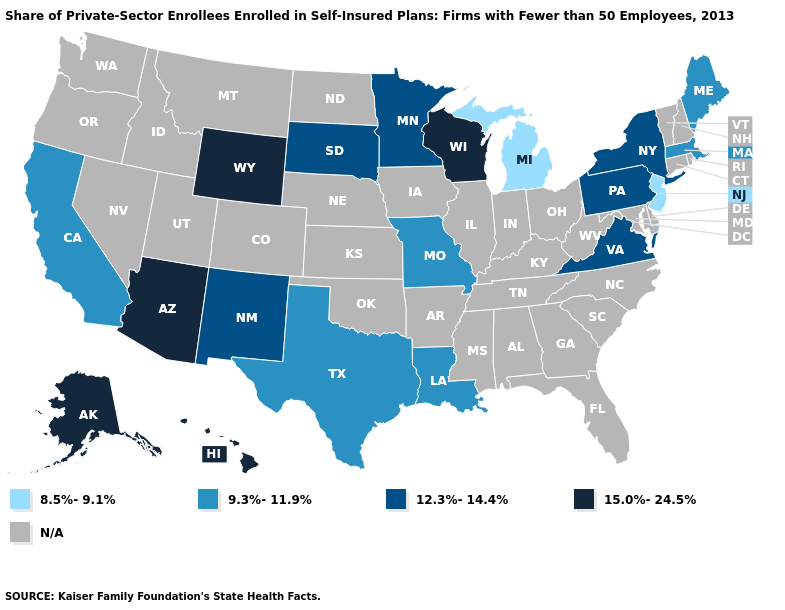Among the states that border New Mexico , does Texas have the highest value?
Be succinct. No. Name the states that have a value in the range N/A?
Keep it brief. Alabama, Arkansas, Colorado, Connecticut, Delaware, Florida, Georgia, Idaho, Illinois, Indiana, Iowa, Kansas, Kentucky, Maryland, Mississippi, Montana, Nebraska, Nevada, New Hampshire, North Carolina, North Dakota, Ohio, Oklahoma, Oregon, Rhode Island, South Carolina, Tennessee, Utah, Vermont, Washington, West Virginia. Name the states that have a value in the range N/A?
Be succinct. Alabama, Arkansas, Colorado, Connecticut, Delaware, Florida, Georgia, Idaho, Illinois, Indiana, Iowa, Kansas, Kentucky, Maryland, Mississippi, Montana, Nebraska, Nevada, New Hampshire, North Carolina, North Dakota, Ohio, Oklahoma, Oregon, Rhode Island, South Carolina, Tennessee, Utah, Vermont, Washington, West Virginia. Name the states that have a value in the range N/A?
Be succinct. Alabama, Arkansas, Colorado, Connecticut, Delaware, Florida, Georgia, Idaho, Illinois, Indiana, Iowa, Kansas, Kentucky, Maryland, Mississippi, Montana, Nebraska, Nevada, New Hampshire, North Carolina, North Dakota, Ohio, Oklahoma, Oregon, Rhode Island, South Carolina, Tennessee, Utah, Vermont, Washington, West Virginia. Name the states that have a value in the range 12.3%-14.4%?
Be succinct. Minnesota, New Mexico, New York, Pennsylvania, South Dakota, Virginia. What is the value of Minnesota?
Write a very short answer. 12.3%-14.4%. Among the states that border Delaware , does New Jersey have the lowest value?
Answer briefly. Yes. What is the value of Massachusetts?
Answer briefly. 9.3%-11.9%. Name the states that have a value in the range N/A?
Concise answer only. Alabama, Arkansas, Colorado, Connecticut, Delaware, Florida, Georgia, Idaho, Illinois, Indiana, Iowa, Kansas, Kentucky, Maryland, Mississippi, Montana, Nebraska, Nevada, New Hampshire, North Carolina, North Dakota, Ohio, Oklahoma, Oregon, Rhode Island, South Carolina, Tennessee, Utah, Vermont, Washington, West Virginia. Does Michigan have the lowest value in the USA?
Keep it brief. Yes. Does Alaska have the highest value in the USA?
Concise answer only. Yes. How many symbols are there in the legend?
Answer briefly. 5. What is the value of Arizona?
Write a very short answer. 15.0%-24.5%. What is the value of Indiana?
Quick response, please. N/A. 